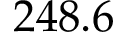<formula> <loc_0><loc_0><loc_500><loc_500>2 4 8 . 6</formula> 